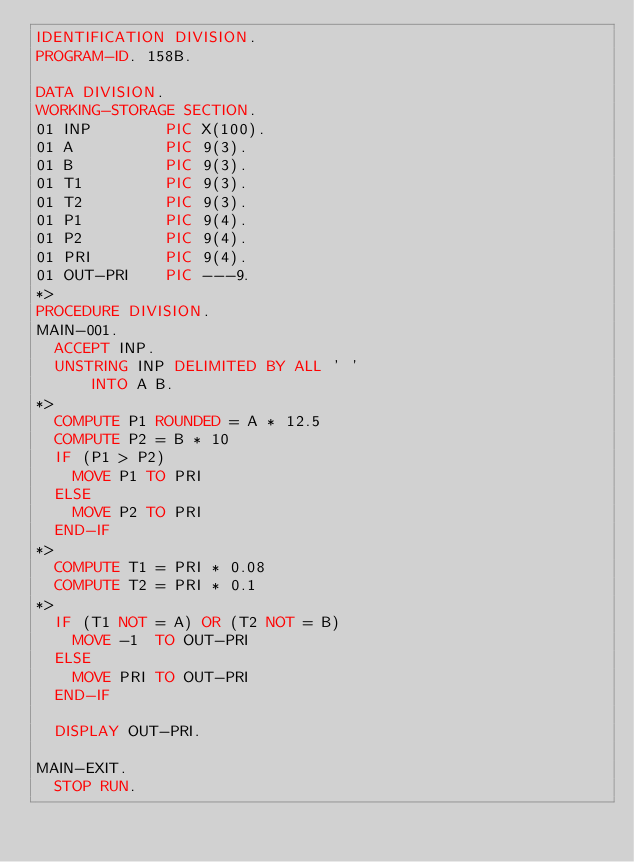<code> <loc_0><loc_0><loc_500><loc_500><_COBOL_>IDENTIFICATION DIVISION.
PROGRAM-ID. 158B.
 
DATA DIVISION.
WORKING-STORAGE SECTION.
01 INP        PIC X(100).
01 A          PIC 9(3).
01 B          PIC 9(3).
01 T1         PIC 9(3).
01 T2         PIC 9(3).
01 P1         PIC 9(4).
01 P2         PIC 9(4).
01 PRI        PIC 9(4).
01 OUT-PRI    PIC ---9.
*> 
PROCEDURE DIVISION.
MAIN-001.
  ACCEPT INP.
  UNSTRING INP DELIMITED BY ALL ' '
      INTO A B.
*>  
  COMPUTE P1 ROUNDED = A * 12.5
  COMPUTE P2 = B * 10
  IF (P1 > P2)
    MOVE P1 TO PRI
  ELSE
    MOVE P2 TO PRI
  END-IF
*>
  COMPUTE T1 = PRI * 0.08
  COMPUTE T2 = PRI * 0.1
*>
  IF (T1 NOT = A) OR (T2 NOT = B)
    MOVE -1  TO OUT-PRI
  ELSE
    MOVE PRI TO OUT-PRI
  END-IF

  DISPLAY OUT-PRI.
 
MAIN-EXIT.
  STOP RUN.
</code> 